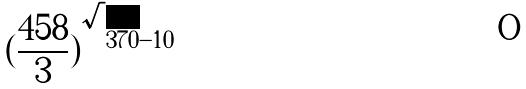<formula> <loc_0><loc_0><loc_500><loc_500>( \frac { 4 5 8 } { 3 } ) ^ { \sqrt { 3 7 0 } - 1 0 }</formula> 